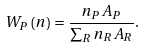<formula> <loc_0><loc_0><loc_500><loc_500>W _ { P } \left ( { n } \right ) = \frac { n _ { P } A _ { P } } { \sum _ { R } n _ { R } A _ { R } } .</formula> 